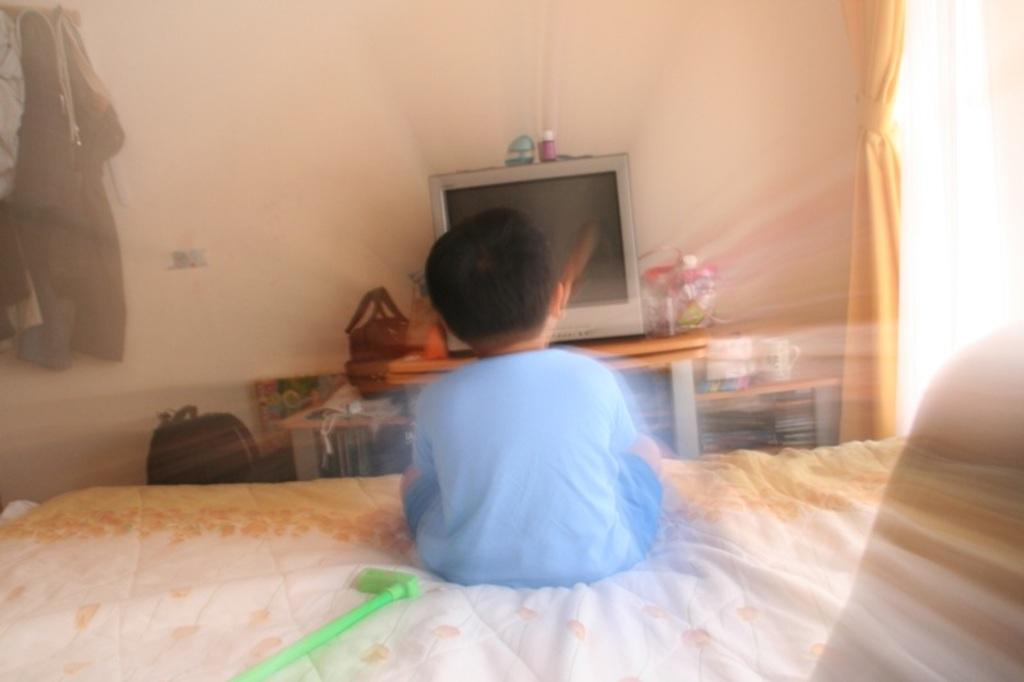What is the child doing in the image? The child is sitting on a bed in the image. What is in front of the child? There is a television in front of the child. What can be seen on a table in the image? There are toys on a table in the image. What is stored on the racks in the image? There are racks with books in the image. What is visible on the wall in the image? There is a wall visible in the image. What is present in the image that might be used for covering or protection? There are clothes and curtains in the image. What architectural feature is visible in the image? There is a window in the image. How does the child beginner to learn a new language in the image? There is no indication in the image that the child is learning a new language or is a beginner at anything. 